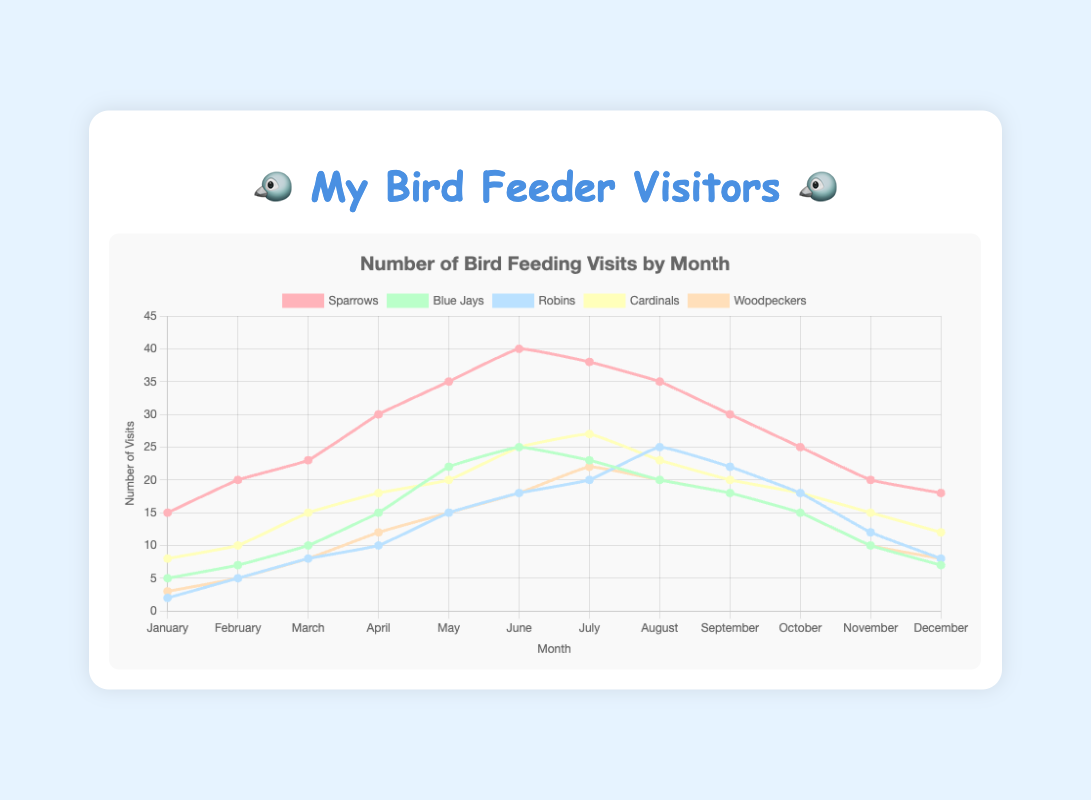Which bird had the most feeding visits in June? In the chart, locate the line for June and compare the heights of the lines for each bird. Identify the bird with the highest point in June.
Answer: Sparrows How many more visits did Blue Jays have in June compared to January? Find the number of visits for Blue Jays in June (25) and January (5), then subtract the January visits from the June visits: 25 - 5 = 20
Answer: 20 In which month did Robins have their highest number of visits? Look for the highest point in the line representing Robins and see which month it falls under.
Answer: August How many total visits did Woodpeckers have from April to July? Locate the numbers corresponding to Woodpeckers for April (12), May (15), June (18), and July (22). Sum them up: 12 + 15 + 18 + 22 = 67
Answer: 67 Which bird had the fewest visits in December, and how many were there? Look at the lines in December and find the lowest point. Identify the bird and its corresponding value for December.
Answer: Robins, 8 Did Cardinals or Sparrows have more visits in October, and by how much? Compare the visits of Cardinals (18) and Sparrows (25) in October. Subtract the smaller number from the larger number: 25 - 18 = 7
Answer: Sparrows, 7 What is the average number of visits per month for Blue Jays? Sum the monthly visits of Blue Jays (5+7+10+15+22+25+23+20+18+15+10+7) to get 177, then divide by 12: 177/12 ≈ 14.75
Answer: ≈ 14.75 How did the feeding visits for Cardinals change from January to July? Check the number of visits in January (8) and compare it with the number in July (27). The change is an increase: 27 - 8 = 19
Answer: Increased by 19 Which two birds had the same number of visits in November? Identify the points on the graph for November and find any matching values.
Answer: Blue Jays and Woodpeckers In which months did Woodpeckers have more visits than Blue Jays? Compare the monthly visits for Woodpeckers and Blue Jays, noting months where Woodpeckers' visits exceed Blue Jays' visits. These months are June, August, September, and October.
Answer: June, August, September, October 